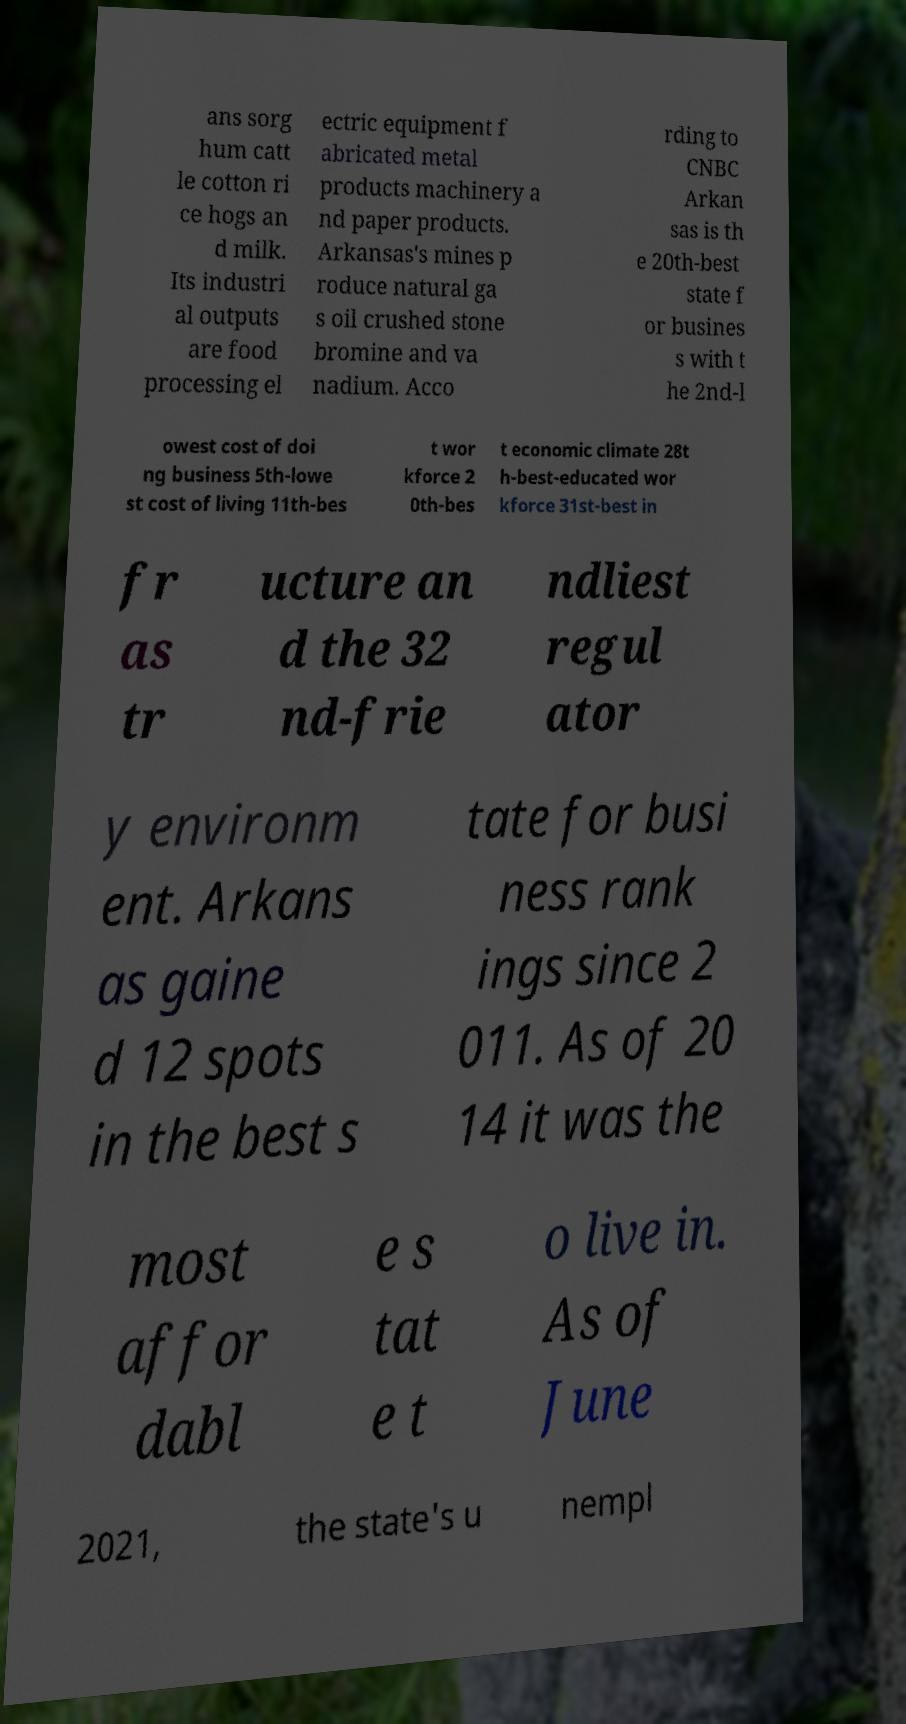What messages or text are displayed in this image? I need them in a readable, typed format. ans sorg hum catt le cotton ri ce hogs an d milk. Its industri al outputs are food processing el ectric equipment f abricated metal products machinery a nd paper products. Arkansas's mines p roduce natural ga s oil crushed stone bromine and va nadium. Acco rding to CNBC Arkan sas is th e 20th-best state f or busines s with t he 2nd-l owest cost of doi ng business 5th-lowe st cost of living 11th-bes t wor kforce 2 0th-bes t economic climate 28t h-best-educated wor kforce 31st-best in fr as tr ucture an d the 32 nd-frie ndliest regul ator y environm ent. Arkans as gaine d 12 spots in the best s tate for busi ness rank ings since 2 011. As of 20 14 it was the most affor dabl e s tat e t o live in. As of June 2021, the state's u nempl 